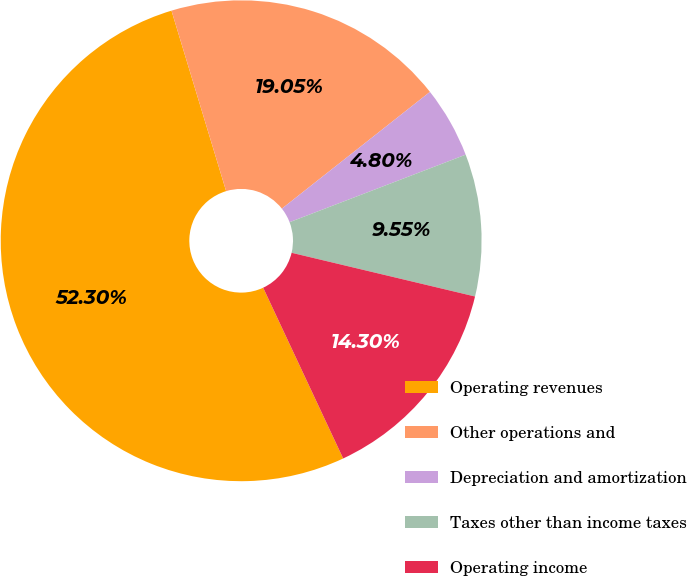<chart> <loc_0><loc_0><loc_500><loc_500><pie_chart><fcel>Operating revenues<fcel>Other operations and<fcel>Depreciation and amortization<fcel>Taxes other than income taxes<fcel>Operating income<nl><fcel>52.29%<fcel>19.05%<fcel>4.8%<fcel>9.55%<fcel>14.3%<nl></chart> 